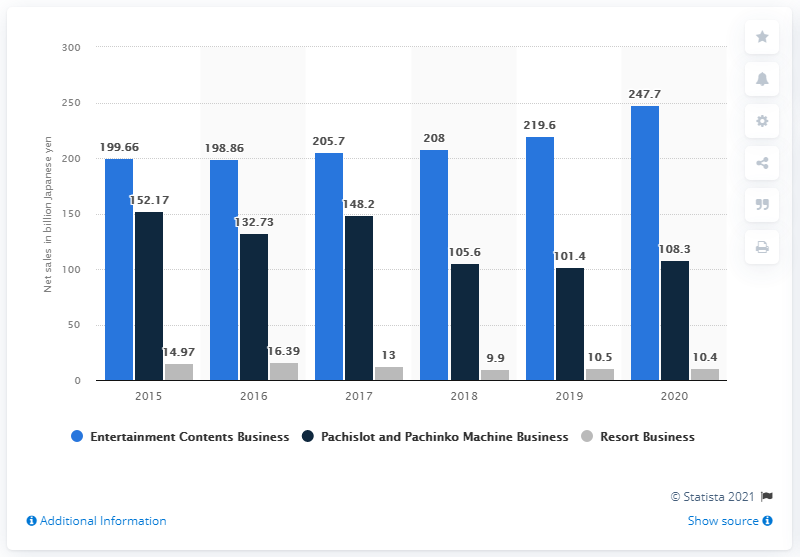Identify some key points in this picture. Sega Sammy generated 108.3 billion Japanese yen in revenue from its Pachislot and Pachinko business in 2021. 